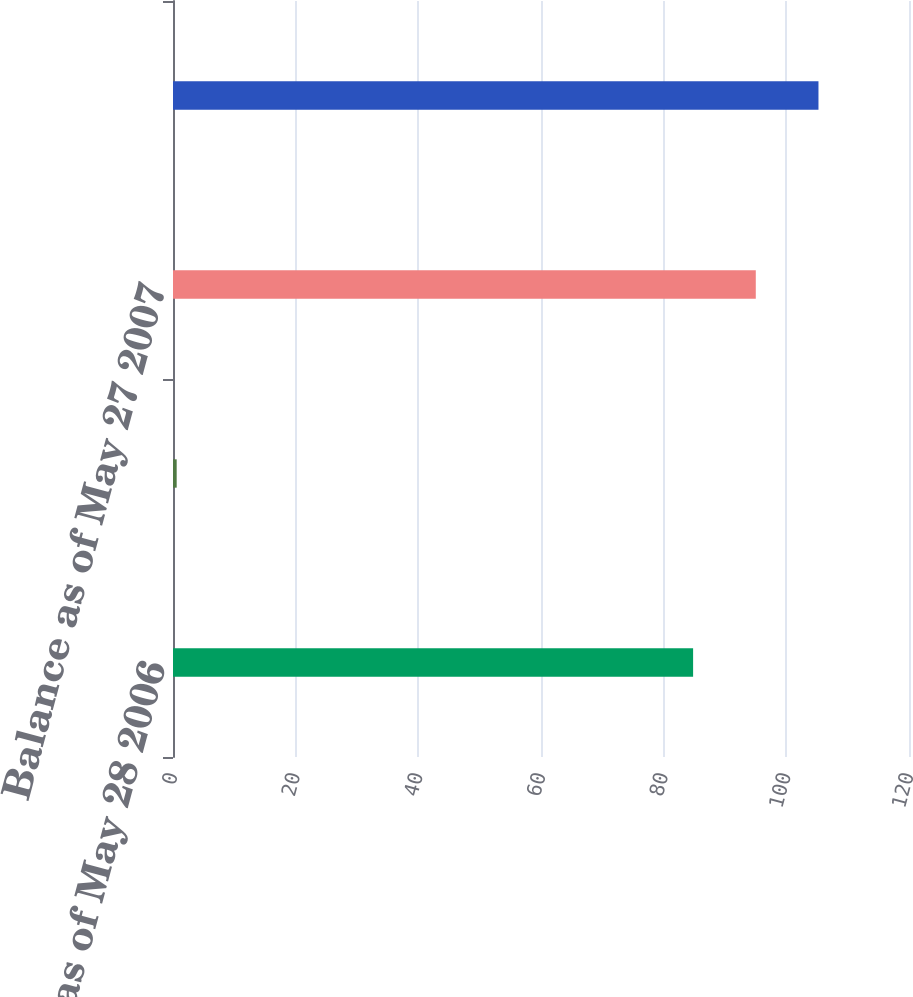Convert chart. <chart><loc_0><loc_0><loc_500><loc_500><bar_chart><fcel>Balance as of May 28 2006<fcel>Translation and other<fcel>Balance as of May 27 2007<fcel>Balance as of May 25 2008<nl><fcel>84.8<fcel>0.6<fcel>95.02<fcel>105.24<nl></chart> 